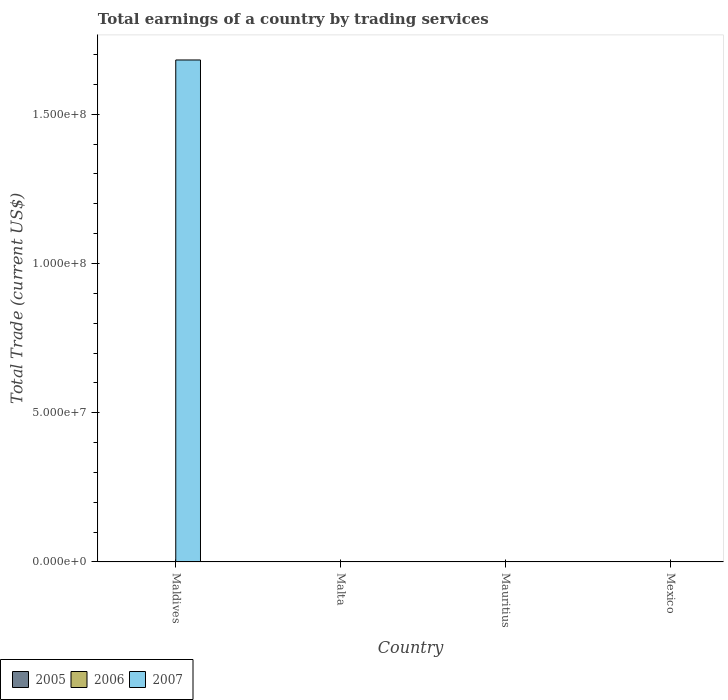How many different coloured bars are there?
Your answer should be very brief. 1. Are the number of bars on each tick of the X-axis equal?
Provide a short and direct response. No. How many bars are there on the 4th tick from the left?
Your answer should be very brief. 0. How many bars are there on the 4th tick from the right?
Give a very brief answer. 1. What is the label of the 3rd group of bars from the left?
Offer a very short reply. Mauritius. In how many cases, is the number of bars for a given country not equal to the number of legend labels?
Make the answer very short. 4. Across all countries, what is the minimum total earnings in 2006?
Ensure brevity in your answer.  0. In which country was the total earnings in 2007 maximum?
Offer a very short reply. Maldives. What is the total total earnings in 2005 in the graph?
Your answer should be compact. 0. What is the difference between the total earnings in 2006 in Maldives and the total earnings in 2005 in Mauritius?
Your answer should be very brief. 0. Are all the bars in the graph horizontal?
Offer a terse response. No. What is the difference between two consecutive major ticks on the Y-axis?
Your answer should be compact. 5.00e+07. How are the legend labels stacked?
Ensure brevity in your answer.  Horizontal. What is the title of the graph?
Provide a short and direct response. Total earnings of a country by trading services. Does "2005" appear as one of the legend labels in the graph?
Make the answer very short. Yes. What is the label or title of the X-axis?
Provide a succinct answer. Country. What is the label or title of the Y-axis?
Offer a terse response. Total Trade (current US$). What is the Total Trade (current US$) of 2005 in Maldives?
Your response must be concise. 0. What is the Total Trade (current US$) of 2006 in Maldives?
Make the answer very short. 0. What is the Total Trade (current US$) of 2007 in Maldives?
Provide a short and direct response. 1.68e+08. What is the Total Trade (current US$) of 2005 in Malta?
Your answer should be very brief. 0. What is the Total Trade (current US$) of 2005 in Mauritius?
Provide a short and direct response. 0. What is the Total Trade (current US$) in 2006 in Mauritius?
Your answer should be compact. 0. What is the Total Trade (current US$) of 2007 in Mauritius?
Your answer should be very brief. 0. Across all countries, what is the maximum Total Trade (current US$) of 2007?
Your response must be concise. 1.68e+08. What is the total Total Trade (current US$) of 2005 in the graph?
Provide a succinct answer. 0. What is the total Total Trade (current US$) in 2006 in the graph?
Provide a succinct answer. 0. What is the total Total Trade (current US$) in 2007 in the graph?
Your response must be concise. 1.68e+08. What is the average Total Trade (current US$) of 2005 per country?
Keep it short and to the point. 0. What is the average Total Trade (current US$) in 2007 per country?
Offer a very short reply. 4.20e+07. What is the difference between the highest and the lowest Total Trade (current US$) of 2007?
Offer a very short reply. 1.68e+08. 